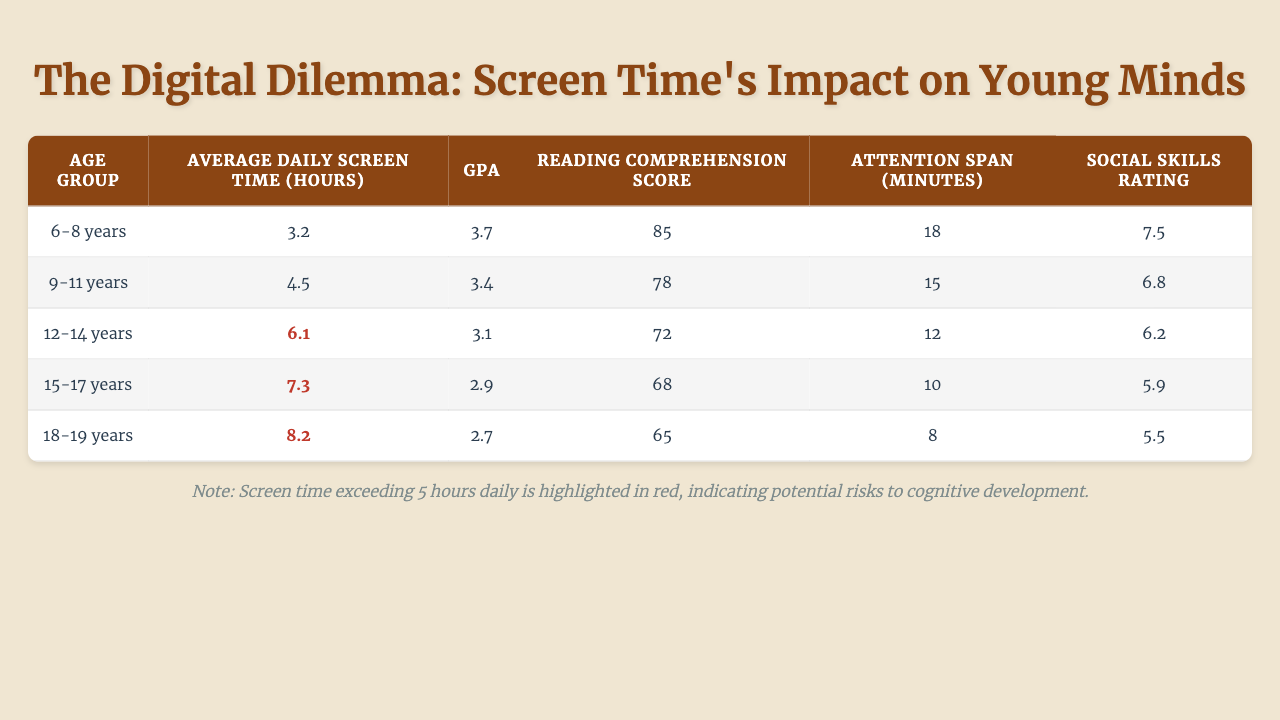What is the average daily screen time for the 12-14 years age group? The table shows that the average daily screen time for the 12-14 years age group is 6.1 hours.
Answer: 6.1 hours What is the GPA of the 6-8 years age group? According to the table, the GPA of the 6-8 years age group is 3.7.
Answer: 3.7 Which age group has the lowest reading comprehension score? The table indicates that the 18-19 years age group has the lowest reading comprehension score, with a score of 65.
Answer: 18-19 years How does the average daily screen time relate to the GPA of 15-17 years age group? The average daily screen time for the 15-17 years age group is 7.3 hours, and the GPA is 2.9, indicating that higher screen time corresponds to a lower GPA.
Answer: Higher screen time corresponds to a lower GPA Is the social skills rating for the 9-11 years age group higher than that of the 12-14 years age group? The social skills rating for the 9-11 years age group is 6.8, while for the 12-14 years age group, it is 6.2. Since 6.8 is greater than 6.2, the 9-11 years age group has a higher social skills rating.
Answer: Yes What is the difference in attention span between the 6-8 years and 15-17 years age groups? The attention span for 6-8 years is 18 minutes and for 15-17 years is 10 minutes. To find the difference, subtract 10 from 18, which equals 8 minutes.
Answer: 8 minutes If the average daily screen time increases by 1 hour, what will be the average for the 18-19 years age group? Currently, the average daily screen time for the 18-19 years age group is 8.2 hours. Increasing it by 1 hour gives us 8.2 + 1 = 9.2 hours.
Answer: 9.2 hours What is the average GPA of all age groups combined? The GPAs from each age group are: 3.7, 3.4, 3.1, 2.9, and 2.7. Adding these gives us 3.7 + 3.4 + 3.1 + 2.9 + 2.7 = 15.8. Dividing by the number of groups (5) gives 15.8 / 5 = 3.16.
Answer: 3.16 Is it true that all age groups with average daily screen time over 5 hours have GPAs lower than 3? The age groups exceeding 5 hours are 12-14 (GPA 3.1), 15-17 (GPA 2.9), and 18-19 (GPA 2.7). While 15-17 and 18-19 are below 3, 12-14 is not. Therefore, not all are below 3.
Answer: No What is the average reading comprehension score for the age group with the highest average daily screen time? The 18-19 years age group has the highest average daily screen time of 8.2 hours and a reading comprehension score of 65. Since it's the highest screen time group, its score is the answer.
Answer: 65 Does higher screen time correlate with lower social skills ratings in the provided data? The data shows that as screen time increases, social skills ratings decrease, with the lowest score at 5.5 for the 18-19 years age group. Therefore, there appears to be a correlation between higher screen time and lower social skills ratings.
Answer: Yes 